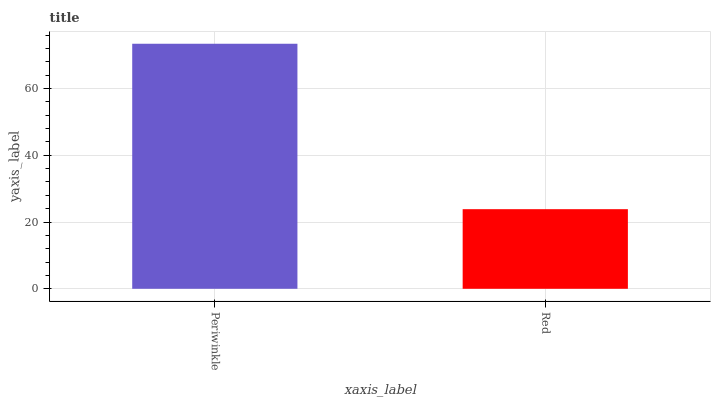Is Red the minimum?
Answer yes or no. Yes. Is Periwinkle the maximum?
Answer yes or no. Yes. Is Red the maximum?
Answer yes or no. No. Is Periwinkle greater than Red?
Answer yes or no. Yes. Is Red less than Periwinkle?
Answer yes or no. Yes. Is Red greater than Periwinkle?
Answer yes or no. No. Is Periwinkle less than Red?
Answer yes or no. No. Is Periwinkle the high median?
Answer yes or no. Yes. Is Red the low median?
Answer yes or no. Yes. Is Red the high median?
Answer yes or no. No. Is Periwinkle the low median?
Answer yes or no. No. 